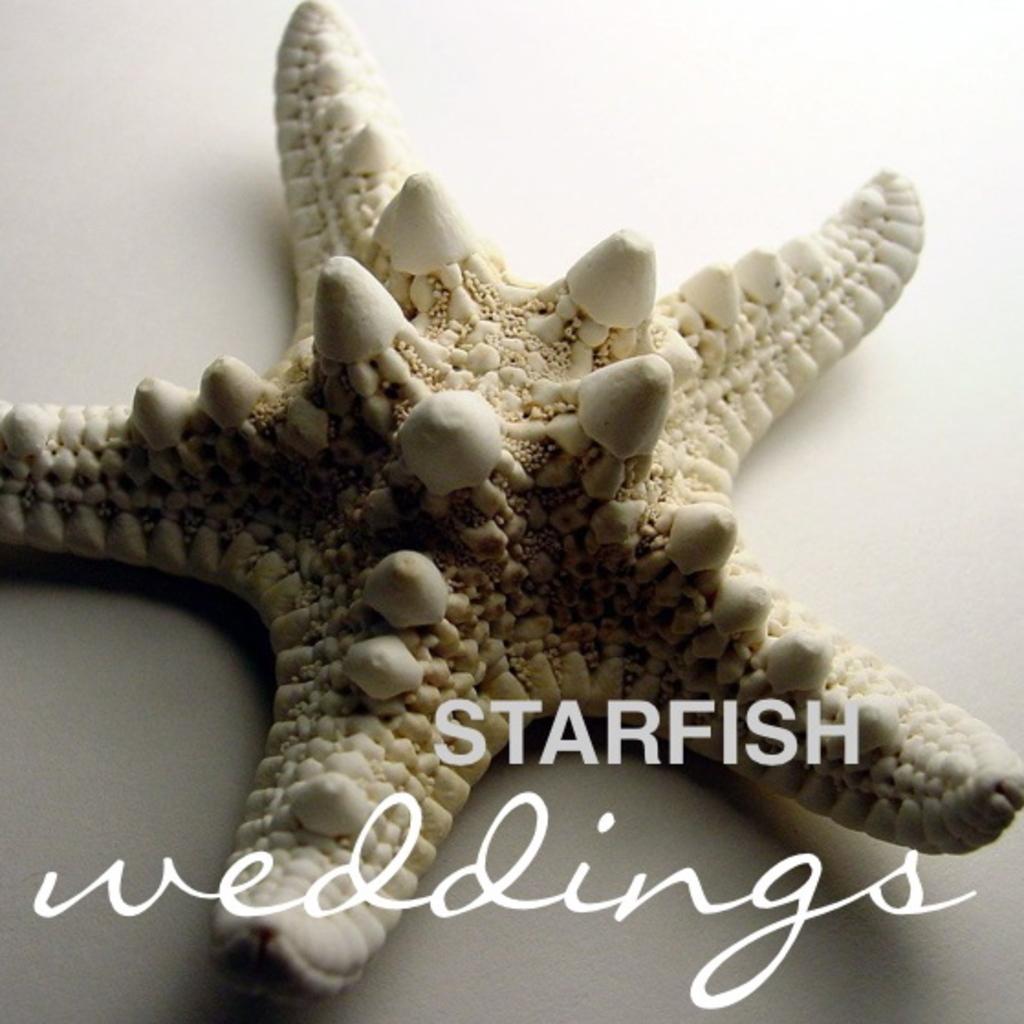Can you describe this image briefly? In this image I can see a starfish and some text at the bottom of the image. 